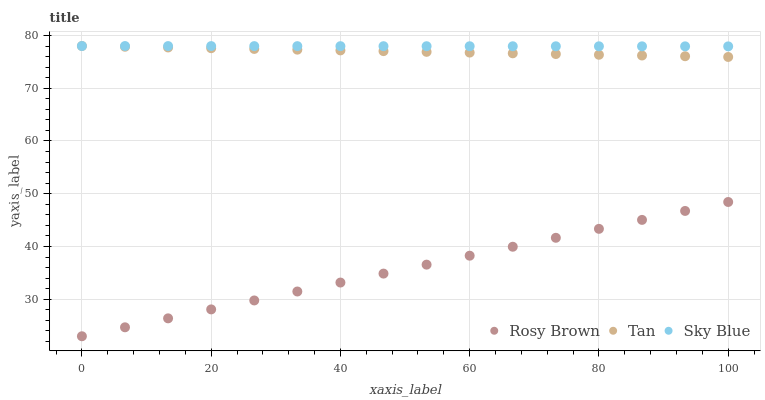Does Rosy Brown have the minimum area under the curve?
Answer yes or no. Yes. Does Sky Blue have the maximum area under the curve?
Answer yes or no. Yes. Does Tan have the minimum area under the curve?
Answer yes or no. No. Does Tan have the maximum area under the curve?
Answer yes or no. No. Is Sky Blue the smoothest?
Answer yes or no. Yes. Is Tan the roughest?
Answer yes or no. Yes. Is Rosy Brown the smoothest?
Answer yes or no. No. Is Rosy Brown the roughest?
Answer yes or no. No. Does Rosy Brown have the lowest value?
Answer yes or no. Yes. Does Tan have the lowest value?
Answer yes or no. No. Does Tan have the highest value?
Answer yes or no. Yes. Does Rosy Brown have the highest value?
Answer yes or no. No. Is Rosy Brown less than Sky Blue?
Answer yes or no. Yes. Is Tan greater than Rosy Brown?
Answer yes or no. Yes. Does Tan intersect Sky Blue?
Answer yes or no. Yes. Is Tan less than Sky Blue?
Answer yes or no. No. Is Tan greater than Sky Blue?
Answer yes or no. No. Does Rosy Brown intersect Sky Blue?
Answer yes or no. No. 